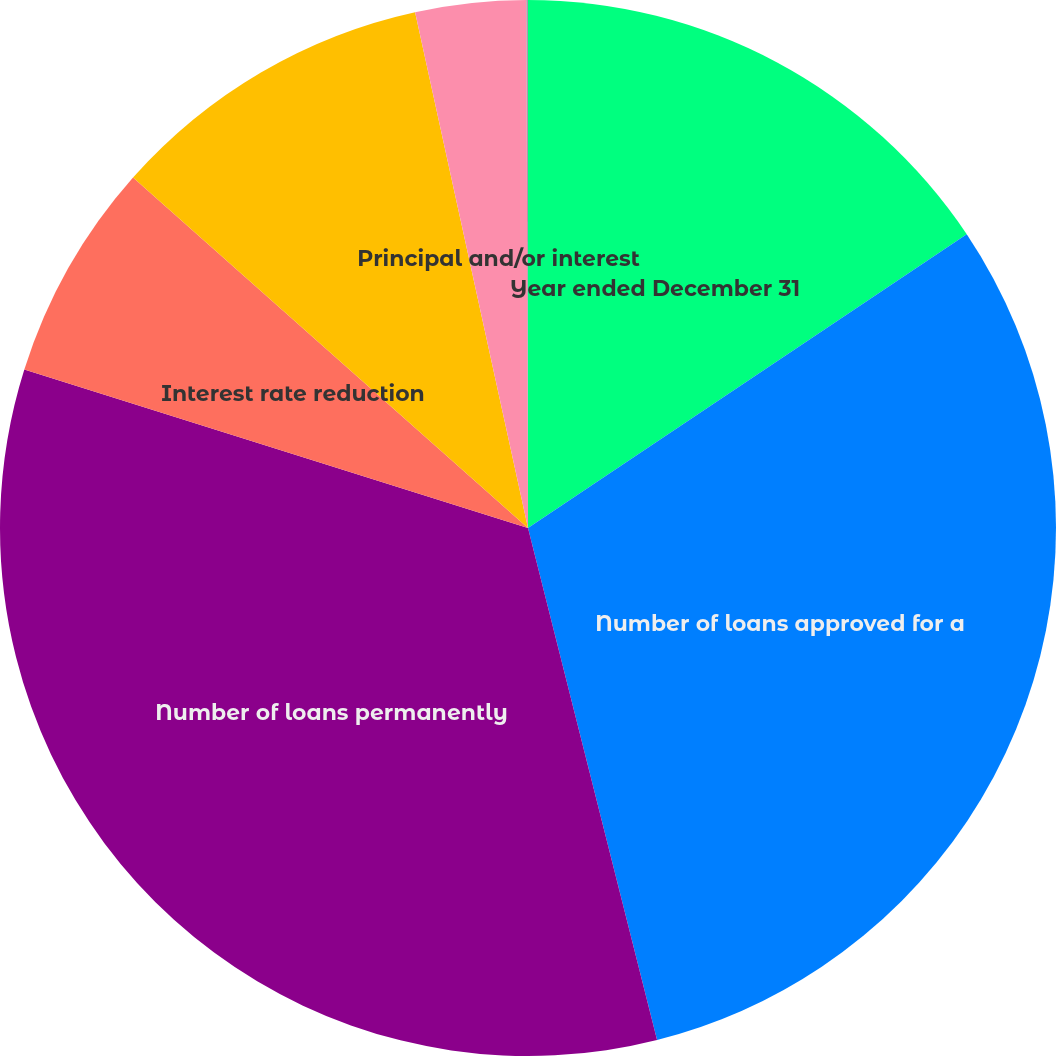Convert chart to OTSL. <chart><loc_0><loc_0><loc_500><loc_500><pie_chart><fcel>Year ended December 31<fcel>Number of loans approved for a<fcel>Number of loans permanently<fcel>Interest rate reduction<fcel>Term or payment extension<fcel>Principal and/or interest<fcel>Principal forgiveness<nl><fcel>15.61%<fcel>30.46%<fcel>33.78%<fcel>6.7%<fcel>10.02%<fcel>3.38%<fcel>0.05%<nl></chart> 